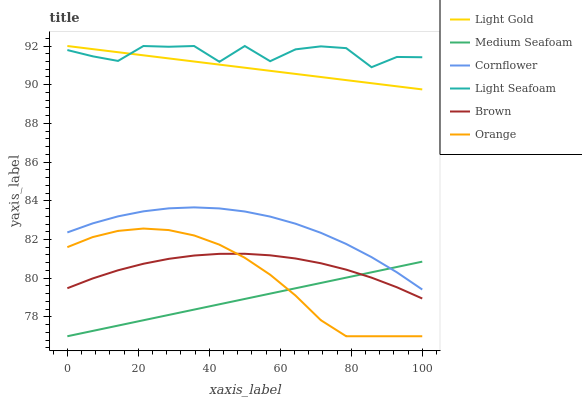Does Medium Seafoam have the minimum area under the curve?
Answer yes or no. Yes. Does Light Seafoam have the maximum area under the curve?
Answer yes or no. Yes. Does Brown have the minimum area under the curve?
Answer yes or no. No. Does Brown have the maximum area under the curve?
Answer yes or no. No. Is Light Gold the smoothest?
Answer yes or no. Yes. Is Light Seafoam the roughest?
Answer yes or no. Yes. Is Brown the smoothest?
Answer yes or no. No. Is Brown the roughest?
Answer yes or no. No. Does Brown have the lowest value?
Answer yes or no. No. Does Light Gold have the highest value?
Answer yes or no. Yes. Does Brown have the highest value?
Answer yes or no. No. Is Medium Seafoam less than Light Gold?
Answer yes or no. Yes. Is Cornflower greater than Orange?
Answer yes or no. Yes. Does Medium Seafoam intersect Brown?
Answer yes or no. Yes. Is Medium Seafoam less than Brown?
Answer yes or no. No. Is Medium Seafoam greater than Brown?
Answer yes or no. No. Does Medium Seafoam intersect Light Gold?
Answer yes or no. No. 